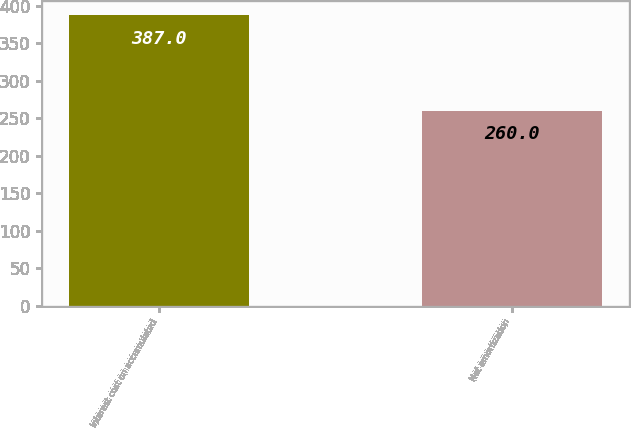<chart> <loc_0><loc_0><loc_500><loc_500><bar_chart><fcel>Interest cost on accumulated<fcel>Net amortization<nl><fcel>387<fcel>260<nl></chart> 